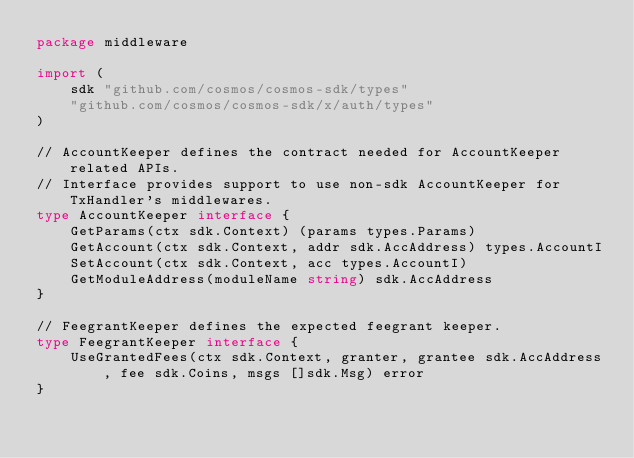Convert code to text. <code><loc_0><loc_0><loc_500><loc_500><_Go_>package middleware

import (
	sdk "github.com/cosmos/cosmos-sdk/types"
	"github.com/cosmos/cosmos-sdk/x/auth/types"
)

// AccountKeeper defines the contract needed for AccountKeeper related APIs.
// Interface provides support to use non-sdk AccountKeeper for TxHandler's middlewares.
type AccountKeeper interface {
	GetParams(ctx sdk.Context) (params types.Params)
	GetAccount(ctx sdk.Context, addr sdk.AccAddress) types.AccountI
	SetAccount(ctx sdk.Context, acc types.AccountI)
	GetModuleAddress(moduleName string) sdk.AccAddress
}

// FeegrantKeeper defines the expected feegrant keeper.
type FeegrantKeeper interface {
	UseGrantedFees(ctx sdk.Context, granter, grantee sdk.AccAddress, fee sdk.Coins, msgs []sdk.Msg) error
}
</code> 